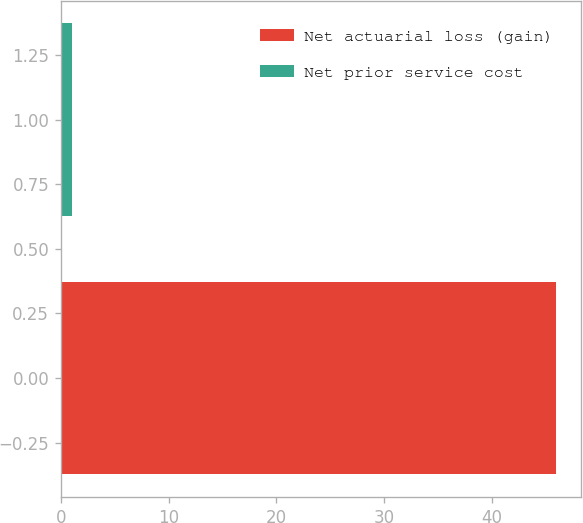<chart> <loc_0><loc_0><loc_500><loc_500><bar_chart><fcel>Net actuarial loss (gain)<fcel>Net prior service cost<nl><fcel>46<fcel>1<nl></chart> 